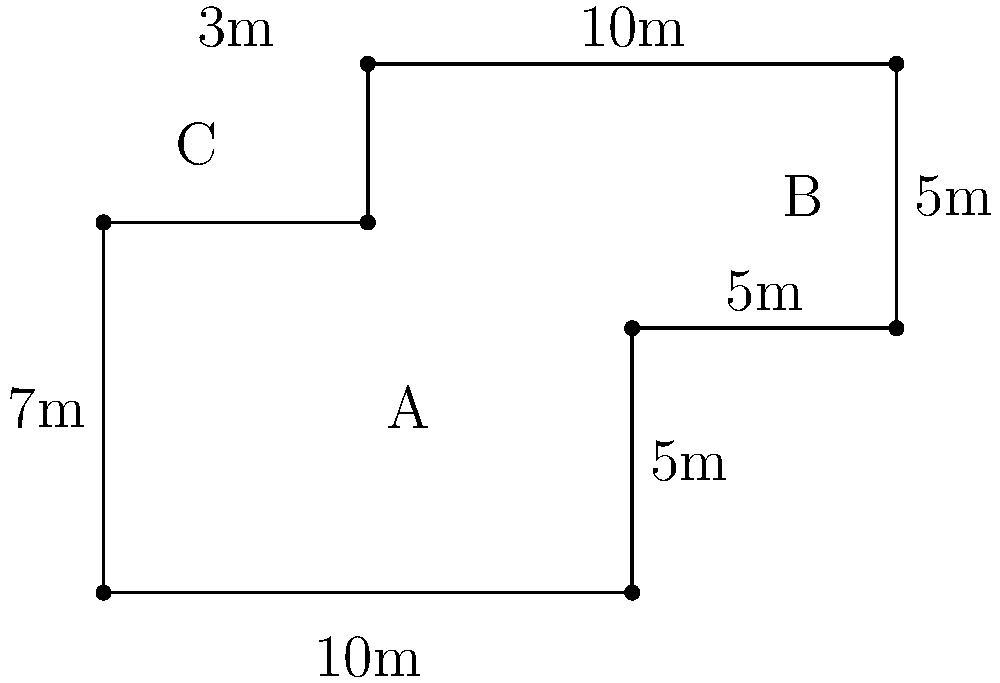As a staff member at Noble's Hospital, you're tasked with calculating the perimeter of a new hospital floor plan. The floor plan is divided into three sections: A, B, and C, as shown in the diagram. Given the measurements provided, what is the total perimeter of the floor plan in meters? To calculate the perimeter, we need to sum up all the outer edges of the floor plan:

1. Bottom edge: $10$ m
2. Right edge (lower part): $5$ m
3. Right edge (upper part): $5$ m
4. Top edge (right part): $10$ m
5. Top edge (left part): $3$ m
6. Left edge (upper part): $3$ m (10 m - 7 m)
7. Left edge (lower part): $7$ m

Now, let's add all these lengths:

$$\text{Perimeter} = 10 + 5 + 5 + 10 + 3 + 3 + 7 = 43 \text{ m}$$

Therefore, the total perimeter of the hospital floor plan is 43 meters.
Answer: 43 m 